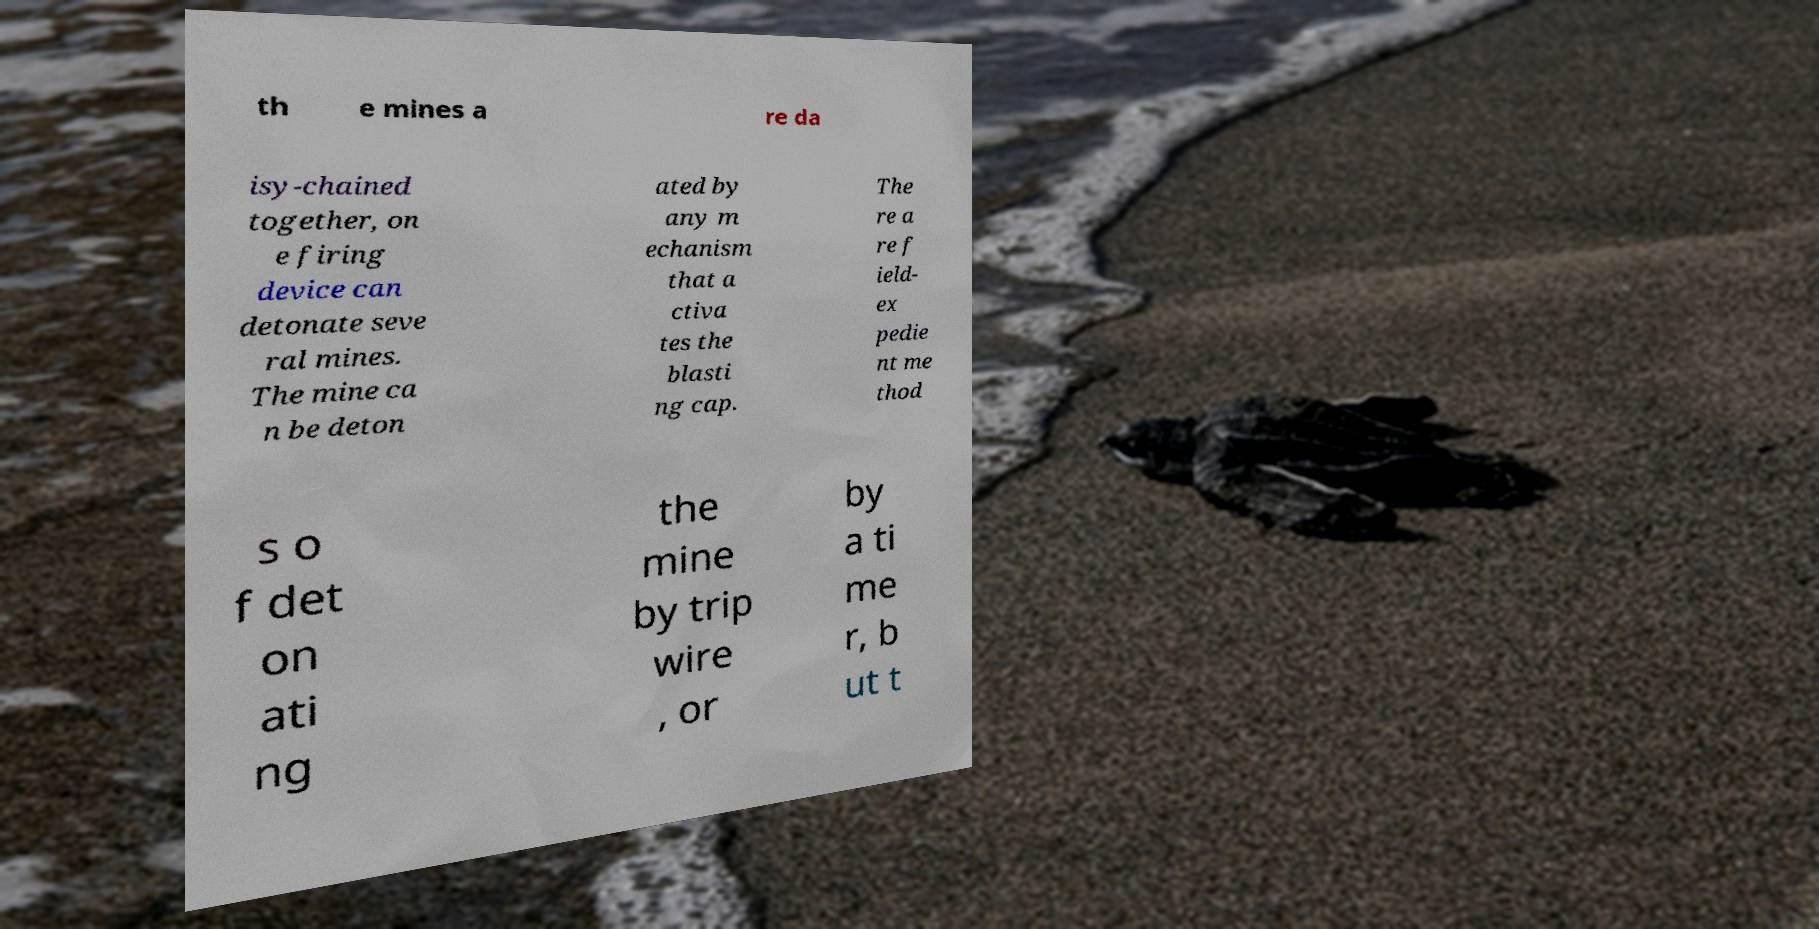Please identify and transcribe the text found in this image. th e mines a re da isy-chained together, on e firing device can detonate seve ral mines. The mine ca n be deton ated by any m echanism that a ctiva tes the blasti ng cap. The re a re f ield- ex pedie nt me thod s o f det on ati ng the mine by trip wire , or by a ti me r, b ut t 